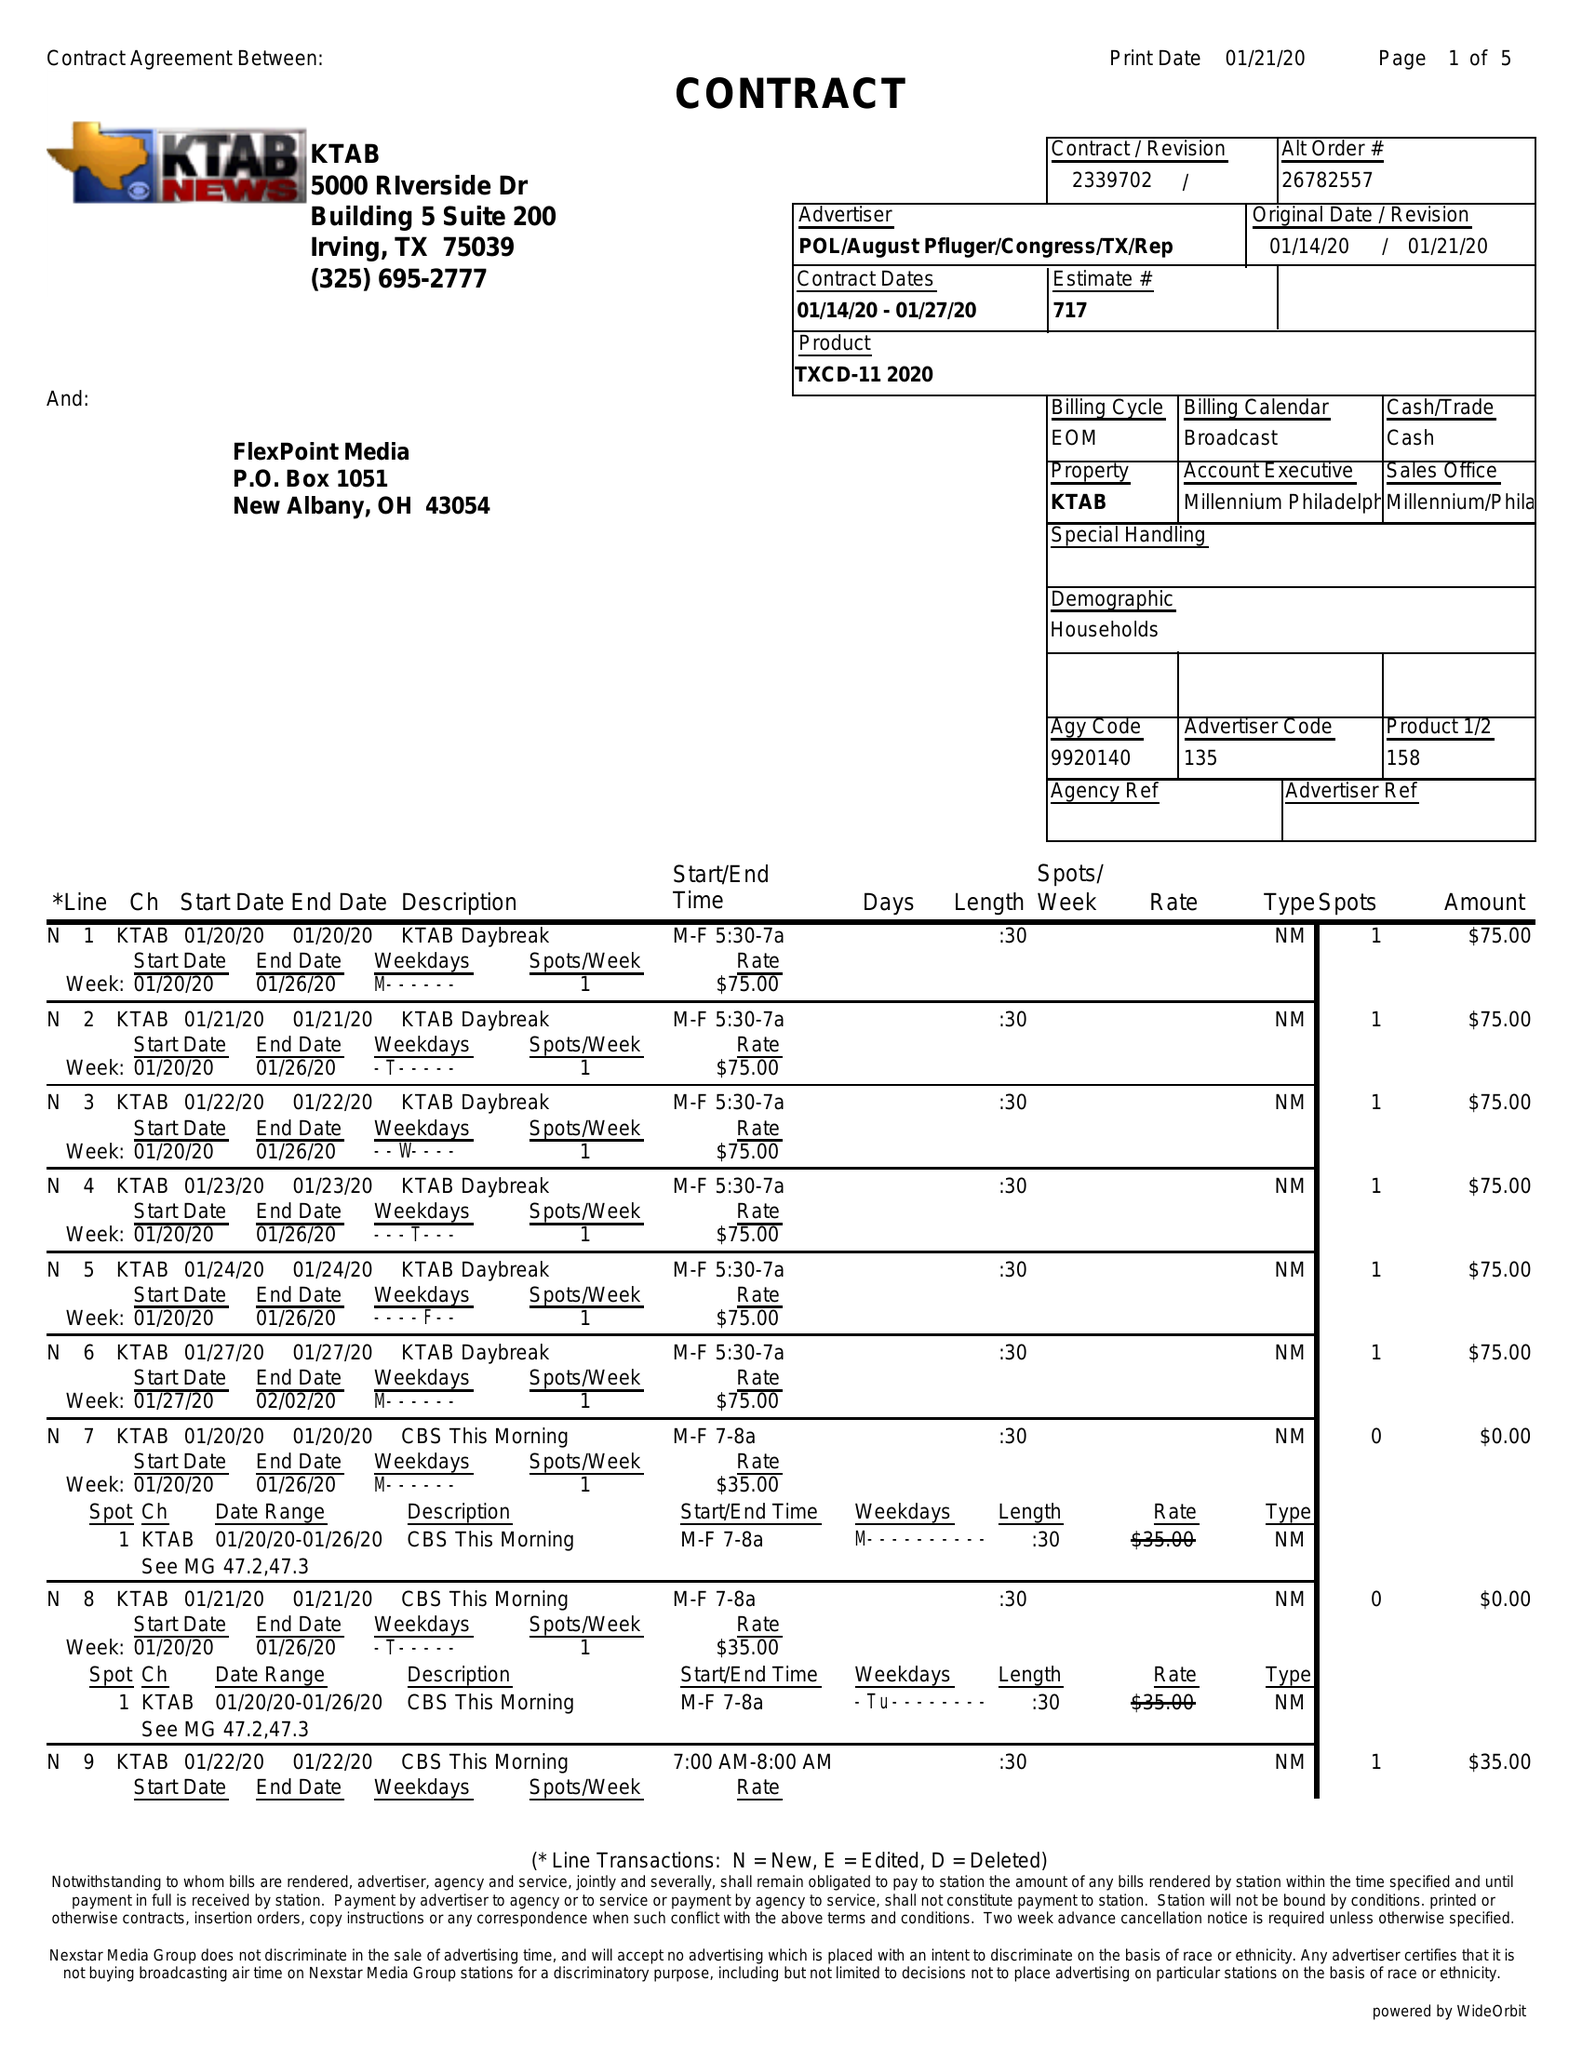What is the value for the contract_num?
Answer the question using a single word or phrase. 2339702 